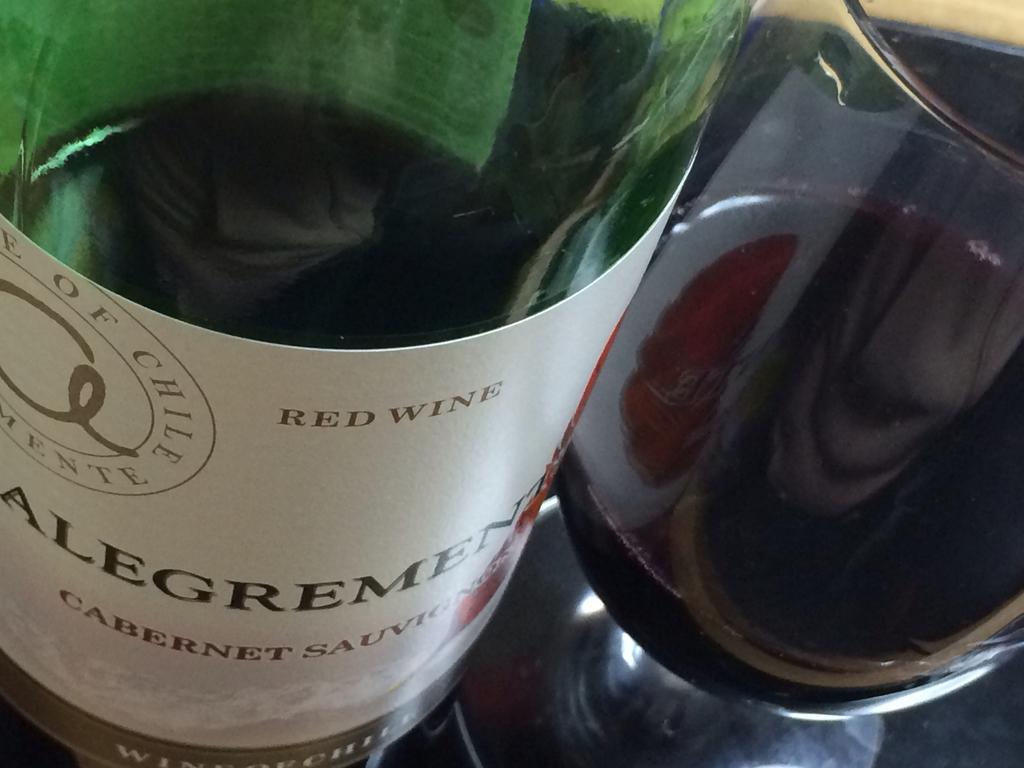What type of beverage is featured in the image? There is a wine bottle and a glass of wine in the image. What object are the wine bottle and glass of wine placed on? The wine bottle and glass of wine are on an object, but the specific type of object is not mentioned in the facts. Can you describe the contents of the wine bottle? The contents of the wine bottle are not visible in the image, so it cannot be determined from the image alone. What type of attraction is present in the image? There is no attraction present in the image; it features a wine bottle and a glass of wine on an object. What type of relation exists between the wine bottle and the glass of wine? The facts provided do not mention any specific relation between the wine bottle and the glass of wine, so it cannot be determined from the image alone. 